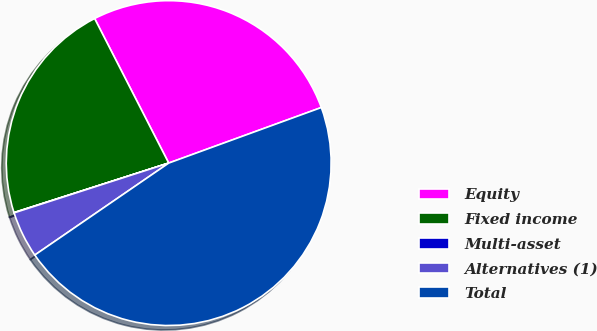<chart> <loc_0><loc_0><loc_500><loc_500><pie_chart><fcel>Equity<fcel>Fixed income<fcel>Multi-asset<fcel>Alternatives (1)<fcel>Total<nl><fcel>26.98%<fcel>22.39%<fcel>0.03%<fcel>4.62%<fcel>45.98%<nl></chart> 